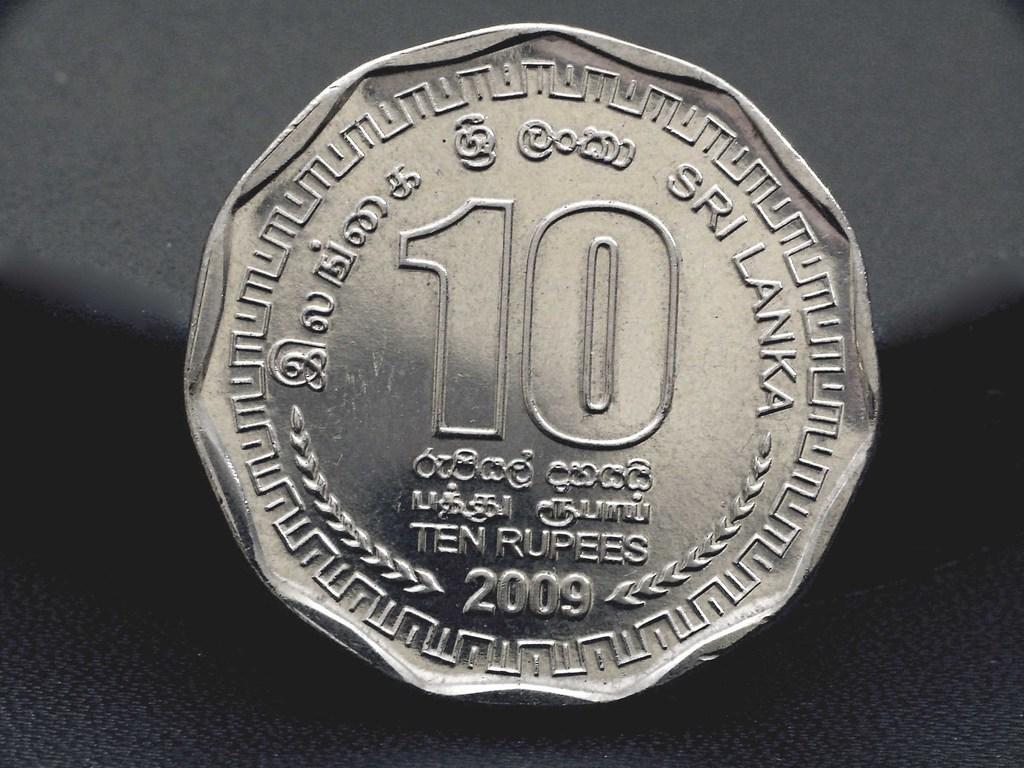Can you describe this image briefly? This picture shows a ten rupees coin and we see a black background. 